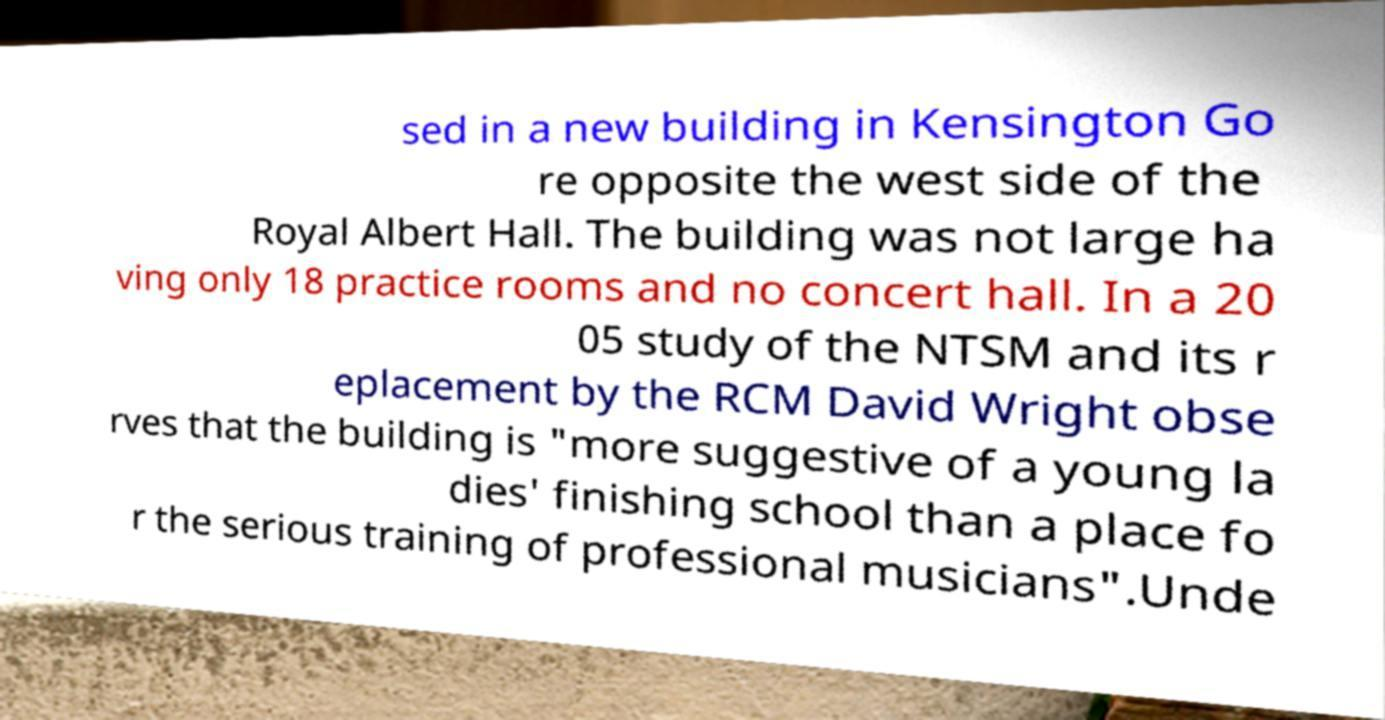Could you assist in decoding the text presented in this image and type it out clearly? sed in a new building in Kensington Go re opposite the west side of the Royal Albert Hall. The building was not large ha ving only 18 practice rooms and no concert hall. In a 20 05 study of the NTSM and its r eplacement by the RCM David Wright obse rves that the building is "more suggestive of a young la dies' finishing school than a place fo r the serious training of professional musicians".Unde 